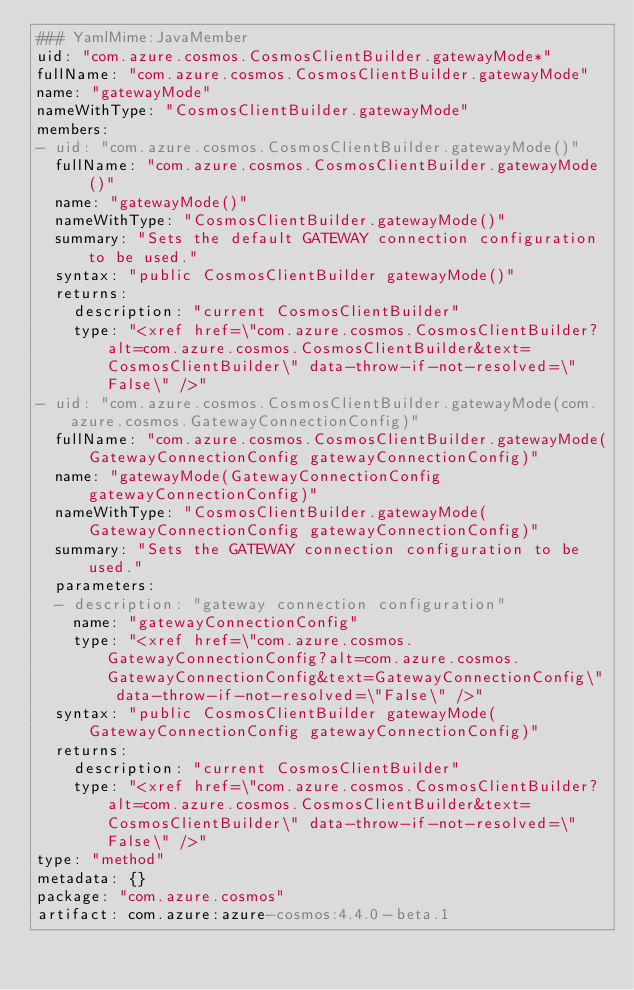Convert code to text. <code><loc_0><loc_0><loc_500><loc_500><_YAML_>### YamlMime:JavaMember
uid: "com.azure.cosmos.CosmosClientBuilder.gatewayMode*"
fullName: "com.azure.cosmos.CosmosClientBuilder.gatewayMode"
name: "gatewayMode"
nameWithType: "CosmosClientBuilder.gatewayMode"
members:
- uid: "com.azure.cosmos.CosmosClientBuilder.gatewayMode()"
  fullName: "com.azure.cosmos.CosmosClientBuilder.gatewayMode()"
  name: "gatewayMode()"
  nameWithType: "CosmosClientBuilder.gatewayMode()"
  summary: "Sets the default GATEWAY connection configuration to be used."
  syntax: "public CosmosClientBuilder gatewayMode()"
  returns:
    description: "current CosmosClientBuilder"
    type: "<xref href=\"com.azure.cosmos.CosmosClientBuilder?alt=com.azure.cosmos.CosmosClientBuilder&text=CosmosClientBuilder\" data-throw-if-not-resolved=\"False\" />"
- uid: "com.azure.cosmos.CosmosClientBuilder.gatewayMode(com.azure.cosmos.GatewayConnectionConfig)"
  fullName: "com.azure.cosmos.CosmosClientBuilder.gatewayMode(GatewayConnectionConfig gatewayConnectionConfig)"
  name: "gatewayMode(GatewayConnectionConfig gatewayConnectionConfig)"
  nameWithType: "CosmosClientBuilder.gatewayMode(GatewayConnectionConfig gatewayConnectionConfig)"
  summary: "Sets the GATEWAY connection configuration to be used."
  parameters:
  - description: "gateway connection configuration"
    name: "gatewayConnectionConfig"
    type: "<xref href=\"com.azure.cosmos.GatewayConnectionConfig?alt=com.azure.cosmos.GatewayConnectionConfig&text=GatewayConnectionConfig\" data-throw-if-not-resolved=\"False\" />"
  syntax: "public CosmosClientBuilder gatewayMode(GatewayConnectionConfig gatewayConnectionConfig)"
  returns:
    description: "current CosmosClientBuilder"
    type: "<xref href=\"com.azure.cosmos.CosmosClientBuilder?alt=com.azure.cosmos.CosmosClientBuilder&text=CosmosClientBuilder\" data-throw-if-not-resolved=\"False\" />"
type: "method"
metadata: {}
package: "com.azure.cosmos"
artifact: com.azure:azure-cosmos:4.4.0-beta.1
</code> 